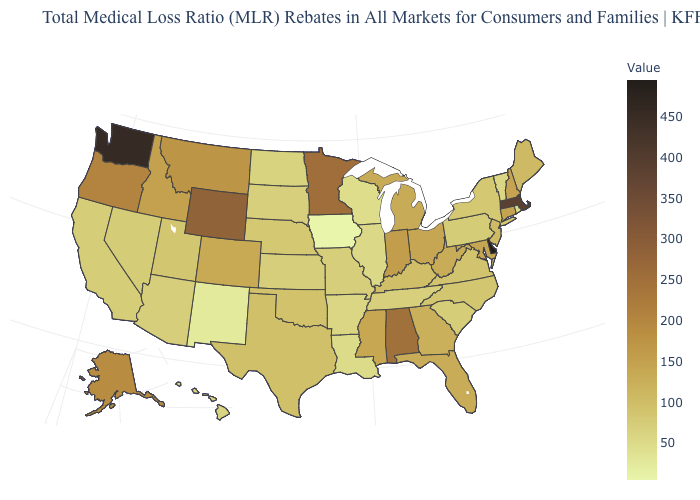Among the states that border Montana , does Wyoming have the highest value?
Be succinct. Yes. Does the map have missing data?
Short answer required. No. Does Minnesota have the highest value in the MidWest?
Be succinct. Yes. Does Florida have the highest value in the South?
Quick response, please. No. Which states have the lowest value in the USA?
Write a very short answer. Iowa. Among the states that border South Dakota , does Wyoming have the highest value?
Answer briefly. Yes. 